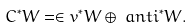Convert formula to latex. <formula><loc_0><loc_0><loc_500><loc_500>C ^ { * } W & = \in v ^ { * } W \oplus \ a n t i ^ { * } W .</formula> 